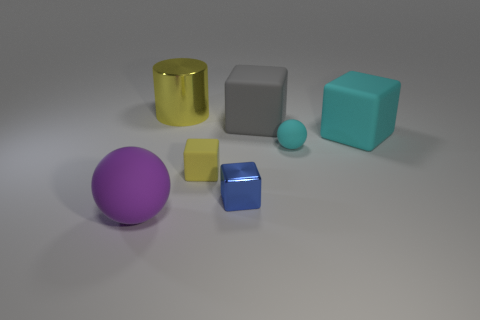There is a cube that is the same color as the tiny sphere; what size is it? large 